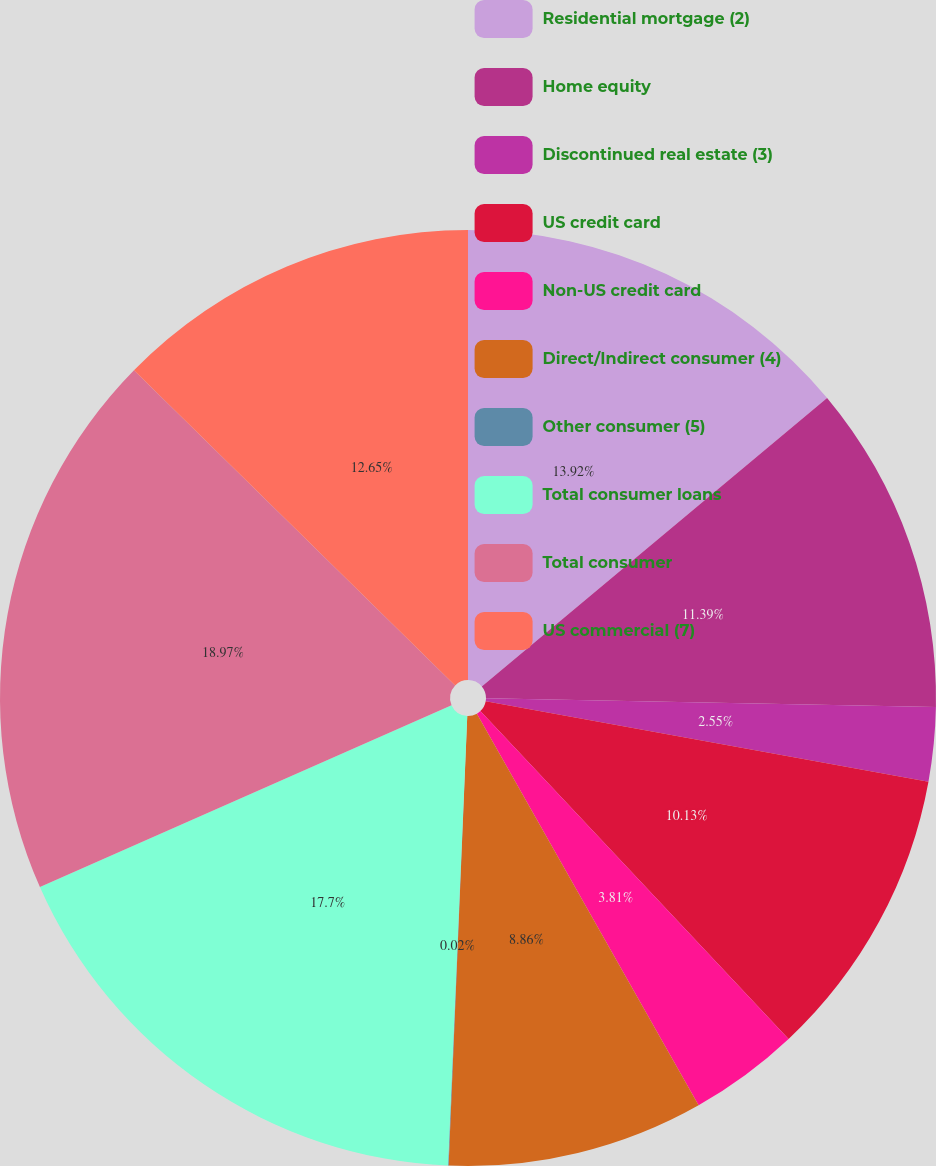Convert chart. <chart><loc_0><loc_0><loc_500><loc_500><pie_chart><fcel>Residential mortgage (2)<fcel>Home equity<fcel>Discontinued real estate (3)<fcel>US credit card<fcel>Non-US credit card<fcel>Direct/Indirect consumer (4)<fcel>Other consumer (5)<fcel>Total consumer loans<fcel>Total consumer<fcel>US commercial (7)<nl><fcel>13.92%<fcel>11.39%<fcel>2.55%<fcel>10.13%<fcel>3.81%<fcel>8.86%<fcel>0.02%<fcel>17.7%<fcel>18.97%<fcel>12.65%<nl></chart> 